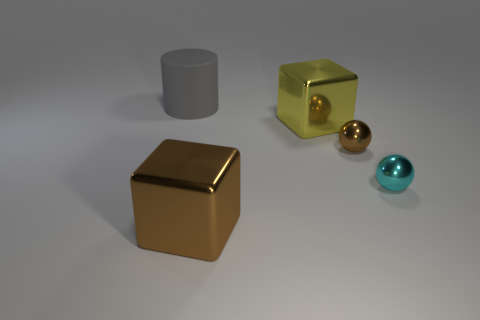How many large cylinders are behind the large cylinder? There are zero large cylinders behind the large cylinder. The visual scene only contains one large cylinder at the front. 